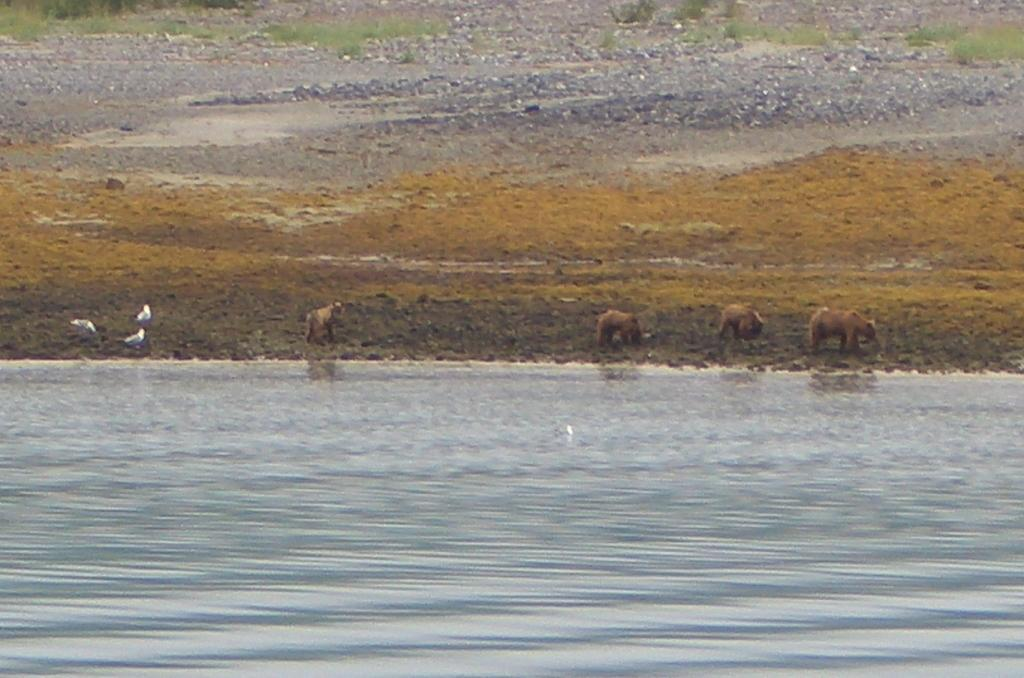What is the primary element present in the image? There is water in the image. What types of living organisms can be seen in the image? Animals and birds are visible in the image. What can be seen in the background of the image? There is grass and plants in the background of the image. What type of chalk can be seen being used by the rabbit in the image? There is no rabbit or chalk present in the image. How many seeds can be seen in the image? There are no seeds visible in the image. 